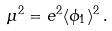<formula> <loc_0><loc_0><loc_500><loc_500>\mu ^ { 2 } = e ^ { 2 } \langle \phi _ { 1 } \rangle ^ { 2 } \, .</formula> 